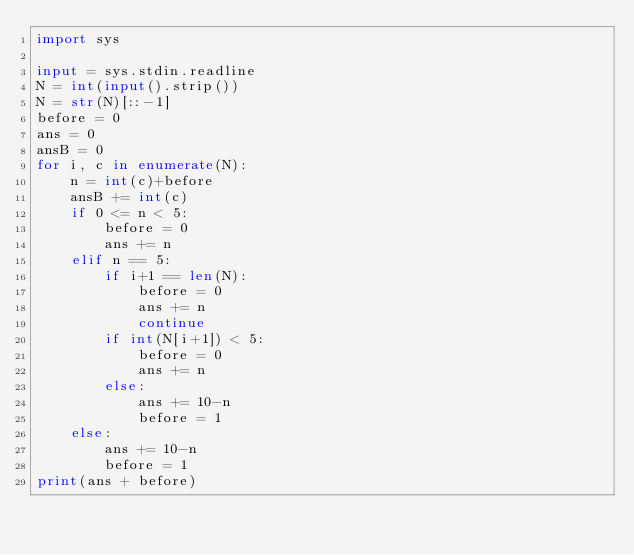<code> <loc_0><loc_0><loc_500><loc_500><_Python_>import sys

input = sys.stdin.readline
N = int(input().strip())
N = str(N)[::-1]
before = 0
ans = 0
ansB = 0
for i, c in enumerate(N):
    n = int(c)+before
    ansB += int(c)
    if 0 <= n < 5:
        before = 0
        ans += n
    elif n == 5:
        if i+1 == len(N):
            before = 0
            ans += n
            continue
        if int(N[i+1]) < 5:
            before = 0
            ans += n
        else:
            ans += 10-n
            before = 1
    else:
        ans += 10-n
        before = 1
print(ans + before)

</code> 